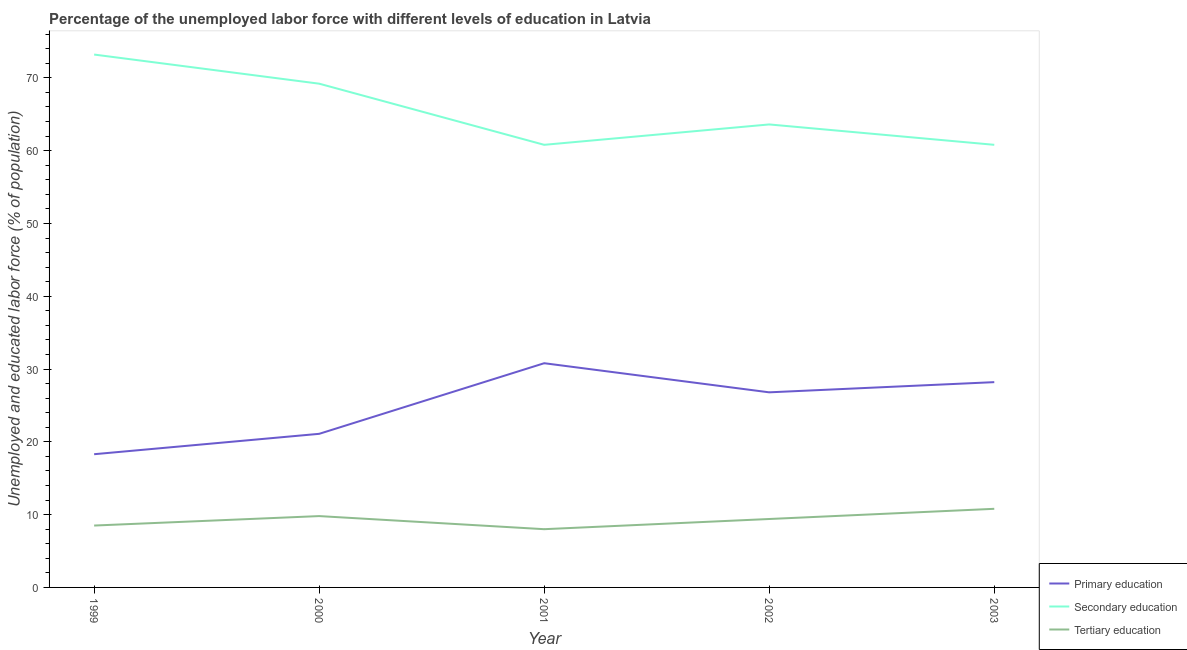How many different coloured lines are there?
Your answer should be very brief. 3. Is the number of lines equal to the number of legend labels?
Provide a succinct answer. Yes. What is the percentage of labor force who received primary education in 2001?
Your answer should be compact. 30.8. Across all years, what is the maximum percentage of labor force who received secondary education?
Provide a succinct answer. 73.2. Across all years, what is the minimum percentage of labor force who received secondary education?
Ensure brevity in your answer.  60.8. In which year was the percentage of labor force who received secondary education maximum?
Your answer should be very brief. 1999. What is the total percentage of labor force who received tertiary education in the graph?
Give a very brief answer. 46.5. What is the difference between the percentage of labor force who received tertiary education in 2000 and that in 2002?
Provide a short and direct response. 0.4. What is the difference between the percentage of labor force who received tertiary education in 1999 and the percentage of labor force who received secondary education in 2002?
Offer a very short reply. -55.1. What is the average percentage of labor force who received secondary education per year?
Your answer should be very brief. 65.52. In the year 2003, what is the difference between the percentage of labor force who received primary education and percentage of labor force who received tertiary education?
Provide a short and direct response. 17.4. In how many years, is the percentage of labor force who received primary education greater than 62 %?
Offer a terse response. 0. What is the ratio of the percentage of labor force who received tertiary education in 1999 to that in 2001?
Keep it short and to the point. 1.06. What is the difference between the highest and the second highest percentage of labor force who received tertiary education?
Provide a succinct answer. 1. What is the difference between the highest and the lowest percentage of labor force who received tertiary education?
Offer a terse response. 2.8. In how many years, is the percentage of labor force who received primary education greater than the average percentage of labor force who received primary education taken over all years?
Give a very brief answer. 3. Is the percentage of labor force who received primary education strictly less than the percentage of labor force who received secondary education over the years?
Provide a short and direct response. Yes. How many lines are there?
Give a very brief answer. 3. Are the values on the major ticks of Y-axis written in scientific E-notation?
Your answer should be compact. No. Does the graph contain any zero values?
Your answer should be very brief. No. Does the graph contain grids?
Your answer should be very brief. No. How are the legend labels stacked?
Offer a terse response. Vertical. What is the title of the graph?
Your response must be concise. Percentage of the unemployed labor force with different levels of education in Latvia. Does "New Zealand" appear as one of the legend labels in the graph?
Give a very brief answer. No. What is the label or title of the Y-axis?
Keep it short and to the point. Unemployed and educated labor force (% of population). What is the Unemployed and educated labor force (% of population) of Primary education in 1999?
Provide a succinct answer. 18.3. What is the Unemployed and educated labor force (% of population) of Secondary education in 1999?
Keep it short and to the point. 73.2. What is the Unemployed and educated labor force (% of population) in Primary education in 2000?
Your answer should be very brief. 21.1. What is the Unemployed and educated labor force (% of population) of Secondary education in 2000?
Your answer should be very brief. 69.2. What is the Unemployed and educated labor force (% of population) in Tertiary education in 2000?
Your response must be concise. 9.8. What is the Unemployed and educated labor force (% of population) of Primary education in 2001?
Keep it short and to the point. 30.8. What is the Unemployed and educated labor force (% of population) in Secondary education in 2001?
Offer a very short reply. 60.8. What is the Unemployed and educated labor force (% of population) of Tertiary education in 2001?
Give a very brief answer. 8. What is the Unemployed and educated labor force (% of population) in Primary education in 2002?
Your answer should be compact. 26.8. What is the Unemployed and educated labor force (% of population) of Secondary education in 2002?
Your answer should be very brief. 63.6. What is the Unemployed and educated labor force (% of population) of Tertiary education in 2002?
Your response must be concise. 9.4. What is the Unemployed and educated labor force (% of population) in Primary education in 2003?
Your response must be concise. 28.2. What is the Unemployed and educated labor force (% of population) of Secondary education in 2003?
Your answer should be very brief. 60.8. What is the Unemployed and educated labor force (% of population) of Tertiary education in 2003?
Give a very brief answer. 10.8. Across all years, what is the maximum Unemployed and educated labor force (% of population) in Primary education?
Provide a succinct answer. 30.8. Across all years, what is the maximum Unemployed and educated labor force (% of population) of Secondary education?
Ensure brevity in your answer.  73.2. Across all years, what is the maximum Unemployed and educated labor force (% of population) in Tertiary education?
Give a very brief answer. 10.8. Across all years, what is the minimum Unemployed and educated labor force (% of population) in Primary education?
Provide a succinct answer. 18.3. Across all years, what is the minimum Unemployed and educated labor force (% of population) of Secondary education?
Keep it short and to the point. 60.8. Across all years, what is the minimum Unemployed and educated labor force (% of population) of Tertiary education?
Your answer should be compact. 8. What is the total Unemployed and educated labor force (% of population) in Primary education in the graph?
Your answer should be very brief. 125.2. What is the total Unemployed and educated labor force (% of population) of Secondary education in the graph?
Provide a short and direct response. 327.6. What is the total Unemployed and educated labor force (% of population) in Tertiary education in the graph?
Give a very brief answer. 46.5. What is the difference between the Unemployed and educated labor force (% of population) in Tertiary education in 1999 and that in 2000?
Give a very brief answer. -1.3. What is the difference between the Unemployed and educated labor force (% of population) in Secondary education in 1999 and that in 2001?
Give a very brief answer. 12.4. What is the difference between the Unemployed and educated labor force (% of population) in Primary education in 1999 and that in 2002?
Your answer should be very brief. -8.5. What is the difference between the Unemployed and educated labor force (% of population) of Primary education in 1999 and that in 2003?
Offer a terse response. -9.9. What is the difference between the Unemployed and educated labor force (% of population) of Secondary education in 1999 and that in 2003?
Offer a very short reply. 12.4. What is the difference between the Unemployed and educated labor force (% of population) in Primary education in 2000 and that in 2001?
Your answer should be very brief. -9.7. What is the difference between the Unemployed and educated labor force (% of population) in Secondary education in 2000 and that in 2001?
Offer a terse response. 8.4. What is the difference between the Unemployed and educated labor force (% of population) of Primary education in 2000 and that in 2003?
Ensure brevity in your answer.  -7.1. What is the difference between the Unemployed and educated labor force (% of population) of Primary education in 2001 and that in 2002?
Your response must be concise. 4. What is the difference between the Unemployed and educated labor force (% of population) in Secondary education in 2001 and that in 2002?
Provide a succinct answer. -2.8. What is the difference between the Unemployed and educated labor force (% of population) of Tertiary education in 2001 and that in 2002?
Ensure brevity in your answer.  -1.4. What is the difference between the Unemployed and educated labor force (% of population) of Secondary education in 2001 and that in 2003?
Offer a terse response. 0. What is the difference between the Unemployed and educated labor force (% of population) of Primary education in 1999 and the Unemployed and educated labor force (% of population) of Secondary education in 2000?
Offer a terse response. -50.9. What is the difference between the Unemployed and educated labor force (% of population) of Secondary education in 1999 and the Unemployed and educated labor force (% of population) of Tertiary education in 2000?
Give a very brief answer. 63.4. What is the difference between the Unemployed and educated labor force (% of population) of Primary education in 1999 and the Unemployed and educated labor force (% of population) of Secondary education in 2001?
Your answer should be compact. -42.5. What is the difference between the Unemployed and educated labor force (% of population) of Secondary education in 1999 and the Unemployed and educated labor force (% of population) of Tertiary education in 2001?
Provide a short and direct response. 65.2. What is the difference between the Unemployed and educated labor force (% of population) of Primary education in 1999 and the Unemployed and educated labor force (% of population) of Secondary education in 2002?
Provide a short and direct response. -45.3. What is the difference between the Unemployed and educated labor force (% of population) in Secondary education in 1999 and the Unemployed and educated labor force (% of population) in Tertiary education in 2002?
Make the answer very short. 63.8. What is the difference between the Unemployed and educated labor force (% of population) in Primary education in 1999 and the Unemployed and educated labor force (% of population) in Secondary education in 2003?
Ensure brevity in your answer.  -42.5. What is the difference between the Unemployed and educated labor force (% of population) in Primary education in 1999 and the Unemployed and educated labor force (% of population) in Tertiary education in 2003?
Your answer should be compact. 7.5. What is the difference between the Unemployed and educated labor force (% of population) of Secondary education in 1999 and the Unemployed and educated labor force (% of population) of Tertiary education in 2003?
Offer a terse response. 62.4. What is the difference between the Unemployed and educated labor force (% of population) in Primary education in 2000 and the Unemployed and educated labor force (% of population) in Secondary education in 2001?
Your response must be concise. -39.7. What is the difference between the Unemployed and educated labor force (% of population) of Primary education in 2000 and the Unemployed and educated labor force (% of population) of Tertiary education in 2001?
Ensure brevity in your answer.  13.1. What is the difference between the Unemployed and educated labor force (% of population) in Secondary education in 2000 and the Unemployed and educated labor force (% of population) in Tertiary education in 2001?
Offer a terse response. 61.2. What is the difference between the Unemployed and educated labor force (% of population) in Primary education in 2000 and the Unemployed and educated labor force (% of population) in Secondary education in 2002?
Provide a short and direct response. -42.5. What is the difference between the Unemployed and educated labor force (% of population) of Secondary education in 2000 and the Unemployed and educated labor force (% of population) of Tertiary education in 2002?
Provide a short and direct response. 59.8. What is the difference between the Unemployed and educated labor force (% of population) in Primary education in 2000 and the Unemployed and educated labor force (% of population) in Secondary education in 2003?
Offer a very short reply. -39.7. What is the difference between the Unemployed and educated labor force (% of population) of Secondary education in 2000 and the Unemployed and educated labor force (% of population) of Tertiary education in 2003?
Your answer should be compact. 58.4. What is the difference between the Unemployed and educated labor force (% of population) of Primary education in 2001 and the Unemployed and educated labor force (% of population) of Secondary education in 2002?
Offer a terse response. -32.8. What is the difference between the Unemployed and educated labor force (% of population) of Primary education in 2001 and the Unemployed and educated labor force (% of population) of Tertiary education in 2002?
Your answer should be compact. 21.4. What is the difference between the Unemployed and educated labor force (% of population) in Secondary education in 2001 and the Unemployed and educated labor force (% of population) in Tertiary education in 2002?
Provide a short and direct response. 51.4. What is the difference between the Unemployed and educated labor force (% of population) of Primary education in 2001 and the Unemployed and educated labor force (% of population) of Secondary education in 2003?
Your response must be concise. -30. What is the difference between the Unemployed and educated labor force (% of population) of Secondary education in 2001 and the Unemployed and educated labor force (% of population) of Tertiary education in 2003?
Give a very brief answer. 50. What is the difference between the Unemployed and educated labor force (% of population) in Primary education in 2002 and the Unemployed and educated labor force (% of population) in Secondary education in 2003?
Provide a succinct answer. -34. What is the difference between the Unemployed and educated labor force (% of population) in Primary education in 2002 and the Unemployed and educated labor force (% of population) in Tertiary education in 2003?
Your response must be concise. 16. What is the difference between the Unemployed and educated labor force (% of population) in Secondary education in 2002 and the Unemployed and educated labor force (% of population) in Tertiary education in 2003?
Provide a succinct answer. 52.8. What is the average Unemployed and educated labor force (% of population) in Primary education per year?
Make the answer very short. 25.04. What is the average Unemployed and educated labor force (% of population) of Secondary education per year?
Make the answer very short. 65.52. What is the average Unemployed and educated labor force (% of population) in Tertiary education per year?
Make the answer very short. 9.3. In the year 1999, what is the difference between the Unemployed and educated labor force (% of population) of Primary education and Unemployed and educated labor force (% of population) of Secondary education?
Provide a short and direct response. -54.9. In the year 1999, what is the difference between the Unemployed and educated labor force (% of population) of Primary education and Unemployed and educated labor force (% of population) of Tertiary education?
Your answer should be compact. 9.8. In the year 1999, what is the difference between the Unemployed and educated labor force (% of population) of Secondary education and Unemployed and educated labor force (% of population) of Tertiary education?
Offer a terse response. 64.7. In the year 2000, what is the difference between the Unemployed and educated labor force (% of population) of Primary education and Unemployed and educated labor force (% of population) of Secondary education?
Make the answer very short. -48.1. In the year 2000, what is the difference between the Unemployed and educated labor force (% of population) in Primary education and Unemployed and educated labor force (% of population) in Tertiary education?
Your answer should be very brief. 11.3. In the year 2000, what is the difference between the Unemployed and educated labor force (% of population) of Secondary education and Unemployed and educated labor force (% of population) of Tertiary education?
Your response must be concise. 59.4. In the year 2001, what is the difference between the Unemployed and educated labor force (% of population) of Primary education and Unemployed and educated labor force (% of population) of Tertiary education?
Give a very brief answer. 22.8. In the year 2001, what is the difference between the Unemployed and educated labor force (% of population) in Secondary education and Unemployed and educated labor force (% of population) in Tertiary education?
Make the answer very short. 52.8. In the year 2002, what is the difference between the Unemployed and educated labor force (% of population) of Primary education and Unemployed and educated labor force (% of population) of Secondary education?
Provide a succinct answer. -36.8. In the year 2002, what is the difference between the Unemployed and educated labor force (% of population) in Secondary education and Unemployed and educated labor force (% of population) in Tertiary education?
Keep it short and to the point. 54.2. In the year 2003, what is the difference between the Unemployed and educated labor force (% of population) in Primary education and Unemployed and educated labor force (% of population) in Secondary education?
Make the answer very short. -32.6. What is the ratio of the Unemployed and educated labor force (% of population) of Primary education in 1999 to that in 2000?
Keep it short and to the point. 0.87. What is the ratio of the Unemployed and educated labor force (% of population) in Secondary education in 1999 to that in 2000?
Your answer should be compact. 1.06. What is the ratio of the Unemployed and educated labor force (% of population) in Tertiary education in 1999 to that in 2000?
Offer a terse response. 0.87. What is the ratio of the Unemployed and educated labor force (% of population) of Primary education in 1999 to that in 2001?
Give a very brief answer. 0.59. What is the ratio of the Unemployed and educated labor force (% of population) of Secondary education in 1999 to that in 2001?
Keep it short and to the point. 1.2. What is the ratio of the Unemployed and educated labor force (% of population) in Primary education in 1999 to that in 2002?
Your answer should be very brief. 0.68. What is the ratio of the Unemployed and educated labor force (% of population) in Secondary education in 1999 to that in 2002?
Your response must be concise. 1.15. What is the ratio of the Unemployed and educated labor force (% of population) in Tertiary education in 1999 to that in 2002?
Keep it short and to the point. 0.9. What is the ratio of the Unemployed and educated labor force (% of population) of Primary education in 1999 to that in 2003?
Your answer should be very brief. 0.65. What is the ratio of the Unemployed and educated labor force (% of population) in Secondary education in 1999 to that in 2003?
Offer a terse response. 1.2. What is the ratio of the Unemployed and educated labor force (% of population) of Tertiary education in 1999 to that in 2003?
Give a very brief answer. 0.79. What is the ratio of the Unemployed and educated labor force (% of population) of Primary education in 2000 to that in 2001?
Offer a very short reply. 0.69. What is the ratio of the Unemployed and educated labor force (% of population) in Secondary education in 2000 to that in 2001?
Give a very brief answer. 1.14. What is the ratio of the Unemployed and educated labor force (% of population) of Tertiary education in 2000 to that in 2001?
Your answer should be compact. 1.23. What is the ratio of the Unemployed and educated labor force (% of population) in Primary education in 2000 to that in 2002?
Provide a succinct answer. 0.79. What is the ratio of the Unemployed and educated labor force (% of population) of Secondary education in 2000 to that in 2002?
Your answer should be very brief. 1.09. What is the ratio of the Unemployed and educated labor force (% of population) in Tertiary education in 2000 to that in 2002?
Give a very brief answer. 1.04. What is the ratio of the Unemployed and educated labor force (% of population) of Primary education in 2000 to that in 2003?
Give a very brief answer. 0.75. What is the ratio of the Unemployed and educated labor force (% of population) in Secondary education in 2000 to that in 2003?
Offer a terse response. 1.14. What is the ratio of the Unemployed and educated labor force (% of population) in Tertiary education in 2000 to that in 2003?
Provide a short and direct response. 0.91. What is the ratio of the Unemployed and educated labor force (% of population) of Primary education in 2001 to that in 2002?
Make the answer very short. 1.15. What is the ratio of the Unemployed and educated labor force (% of population) of Secondary education in 2001 to that in 2002?
Your answer should be compact. 0.96. What is the ratio of the Unemployed and educated labor force (% of population) of Tertiary education in 2001 to that in 2002?
Offer a very short reply. 0.85. What is the ratio of the Unemployed and educated labor force (% of population) in Primary education in 2001 to that in 2003?
Ensure brevity in your answer.  1.09. What is the ratio of the Unemployed and educated labor force (% of population) in Secondary education in 2001 to that in 2003?
Your response must be concise. 1. What is the ratio of the Unemployed and educated labor force (% of population) in Tertiary education in 2001 to that in 2003?
Provide a short and direct response. 0.74. What is the ratio of the Unemployed and educated labor force (% of population) in Primary education in 2002 to that in 2003?
Keep it short and to the point. 0.95. What is the ratio of the Unemployed and educated labor force (% of population) of Secondary education in 2002 to that in 2003?
Make the answer very short. 1.05. What is the ratio of the Unemployed and educated labor force (% of population) of Tertiary education in 2002 to that in 2003?
Offer a very short reply. 0.87. What is the difference between the highest and the second highest Unemployed and educated labor force (% of population) in Tertiary education?
Keep it short and to the point. 1. What is the difference between the highest and the lowest Unemployed and educated labor force (% of population) of Primary education?
Provide a succinct answer. 12.5. What is the difference between the highest and the lowest Unemployed and educated labor force (% of population) of Tertiary education?
Provide a succinct answer. 2.8. 